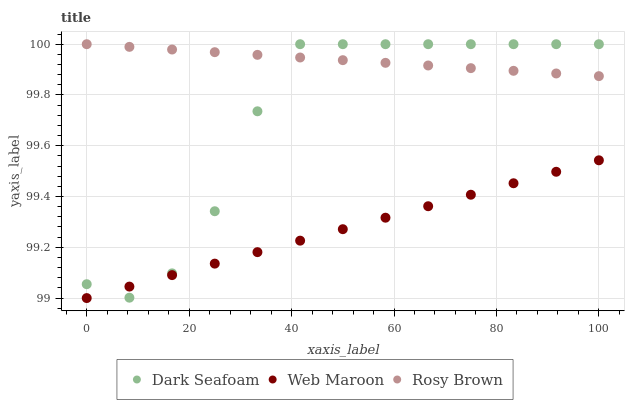Does Web Maroon have the minimum area under the curve?
Answer yes or no. Yes. Does Rosy Brown have the maximum area under the curve?
Answer yes or no. Yes. Does Rosy Brown have the minimum area under the curve?
Answer yes or no. No. Does Web Maroon have the maximum area under the curve?
Answer yes or no. No. Is Web Maroon the smoothest?
Answer yes or no. Yes. Is Dark Seafoam the roughest?
Answer yes or no. Yes. Is Rosy Brown the smoothest?
Answer yes or no. No. Is Rosy Brown the roughest?
Answer yes or no. No. Does Web Maroon have the lowest value?
Answer yes or no. Yes. Does Rosy Brown have the lowest value?
Answer yes or no. No. Does Rosy Brown have the highest value?
Answer yes or no. Yes. Does Web Maroon have the highest value?
Answer yes or no. No. Is Web Maroon less than Rosy Brown?
Answer yes or no. Yes. Is Rosy Brown greater than Web Maroon?
Answer yes or no. Yes. Does Rosy Brown intersect Dark Seafoam?
Answer yes or no. Yes. Is Rosy Brown less than Dark Seafoam?
Answer yes or no. No. Is Rosy Brown greater than Dark Seafoam?
Answer yes or no. No. Does Web Maroon intersect Rosy Brown?
Answer yes or no. No. 